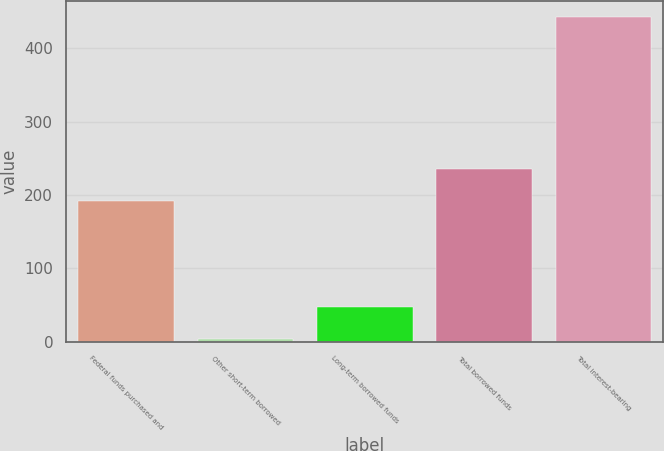<chart> <loc_0><loc_0><loc_500><loc_500><bar_chart><fcel>Federal funds purchased and<fcel>Other short-term borrowed<fcel>Long-term borrowed funds<fcel>Total borrowed funds<fcel>Total interest-bearing<nl><fcel>192<fcel>4<fcel>47.9<fcel>235.9<fcel>443<nl></chart> 